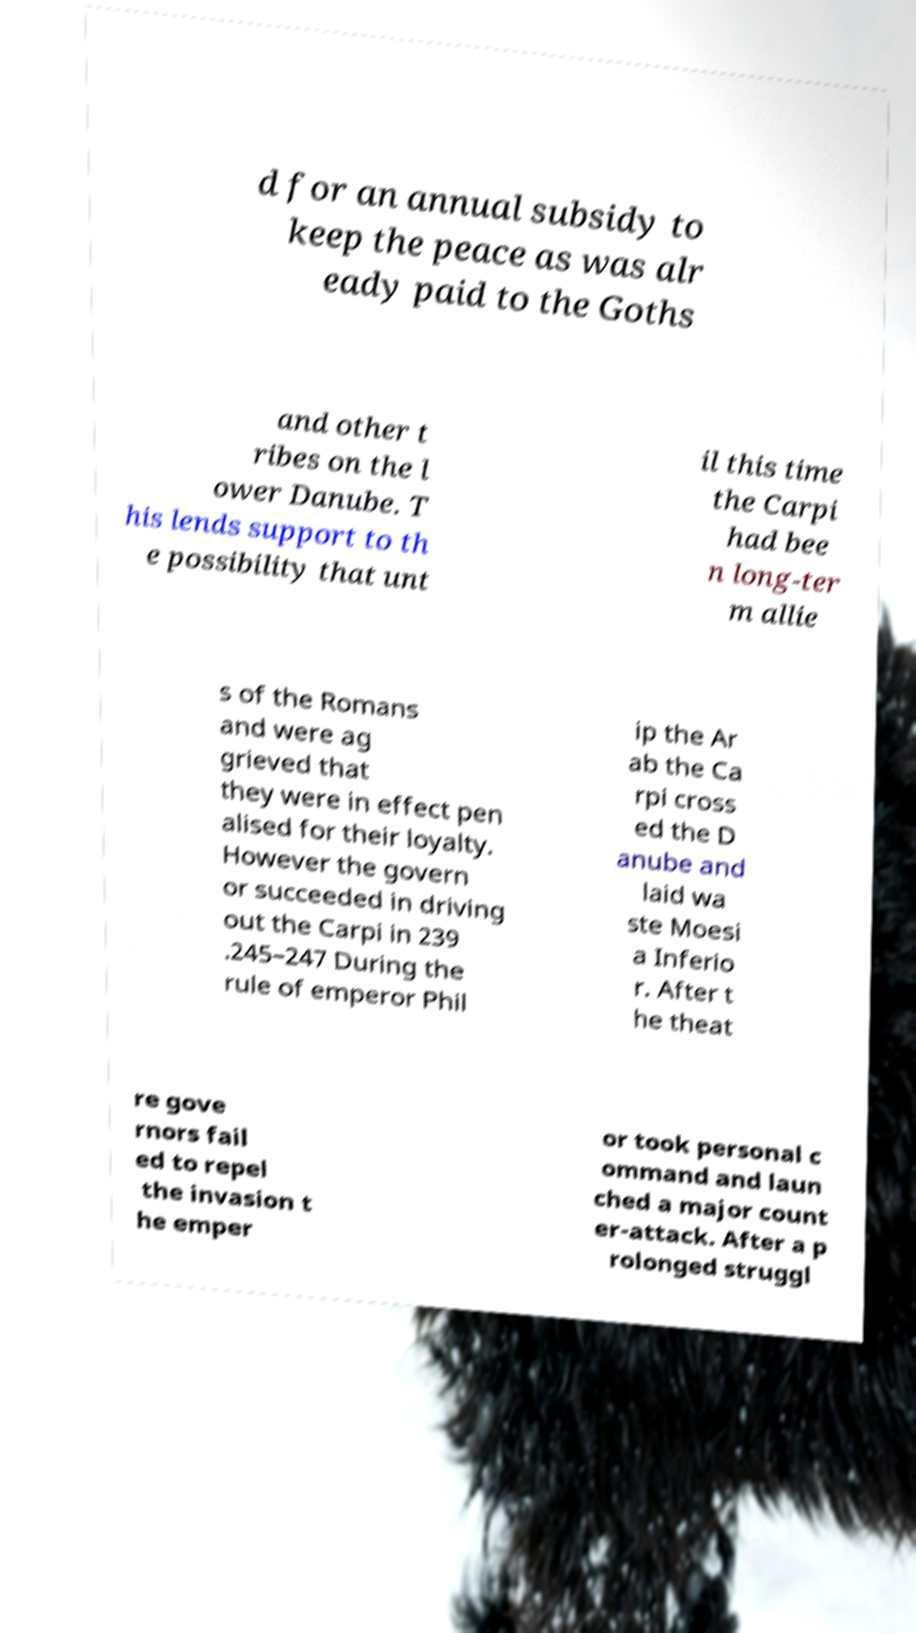Can you accurately transcribe the text from the provided image for me? d for an annual subsidy to keep the peace as was alr eady paid to the Goths and other t ribes on the l ower Danube. T his lends support to th e possibility that unt il this time the Carpi had bee n long-ter m allie s of the Romans and were ag grieved that they were in effect pen alised for their loyalty. However the govern or succeeded in driving out the Carpi in 239 .245–247 During the rule of emperor Phil ip the Ar ab the Ca rpi cross ed the D anube and laid wa ste Moesi a Inferio r. After t he theat re gove rnors fail ed to repel the invasion t he emper or took personal c ommand and laun ched a major count er-attack. After a p rolonged struggl 